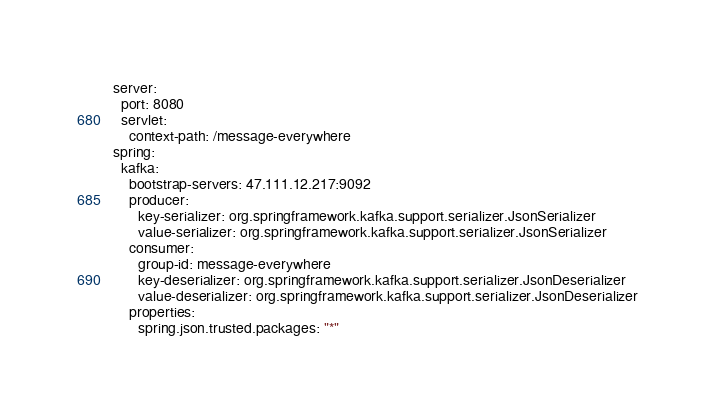Convert code to text. <code><loc_0><loc_0><loc_500><loc_500><_YAML_>server:
  port: 8080
  servlet:
    context-path: /message-everywhere
spring:
  kafka:
    bootstrap-servers: 47.111.12.217:9092
    producer:
      key-serializer: org.springframework.kafka.support.serializer.JsonSerializer
      value-serializer: org.springframework.kafka.support.serializer.JsonSerializer
    consumer:
      group-id: message-everywhere
      key-deserializer: org.springframework.kafka.support.serializer.JsonDeserializer
      value-deserializer: org.springframework.kafka.support.serializer.JsonDeserializer
    properties:
      spring.json.trusted.packages: "*"</code> 